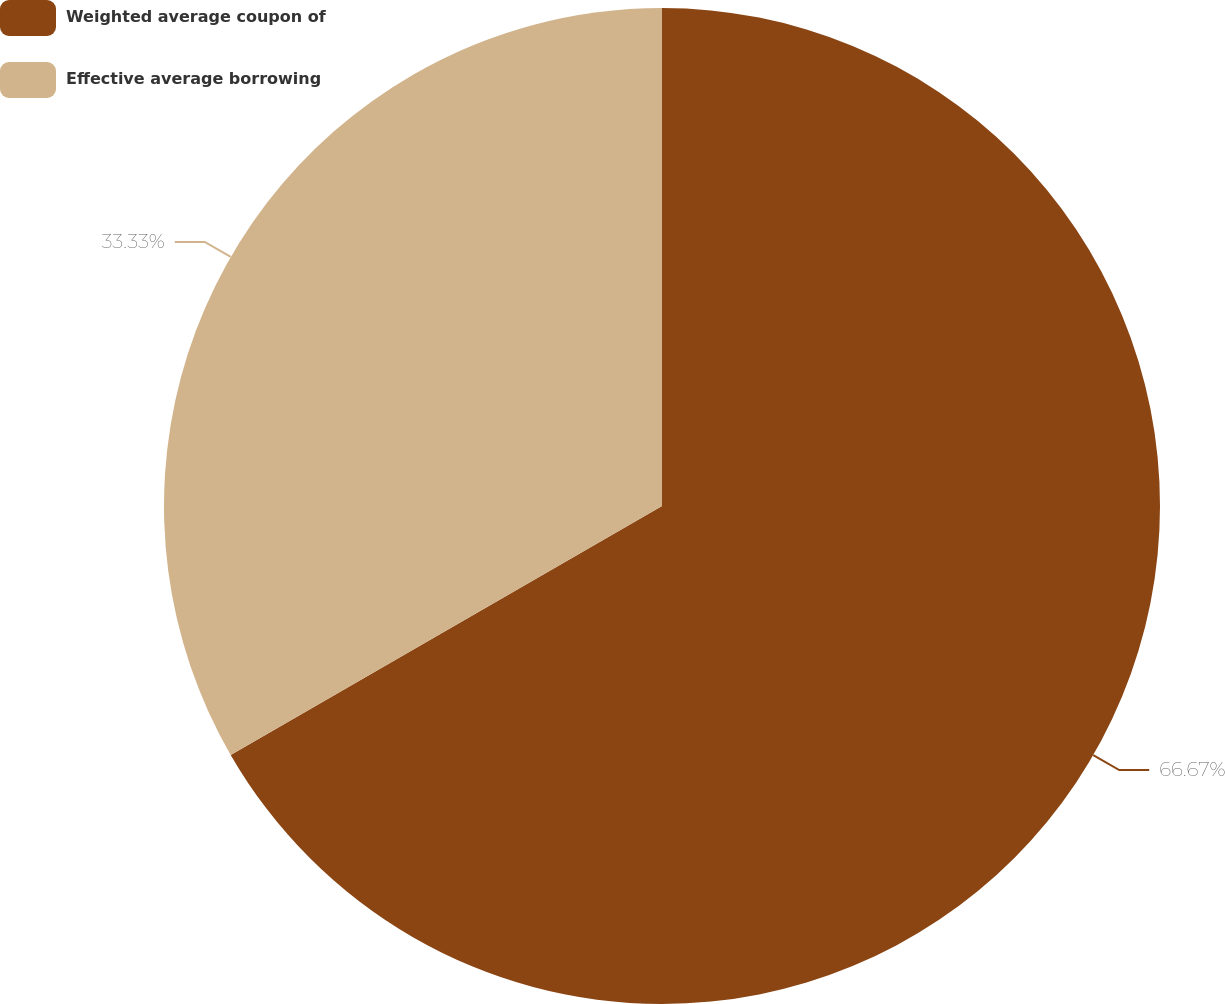Convert chart. <chart><loc_0><loc_0><loc_500><loc_500><pie_chart><fcel>Weighted average coupon of<fcel>Effective average borrowing<nl><fcel>66.67%<fcel>33.33%<nl></chart> 